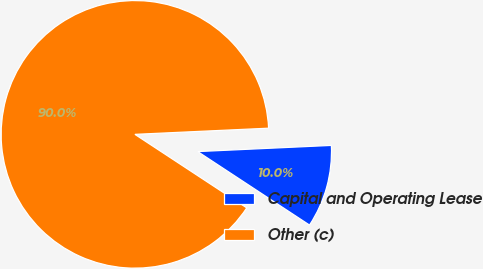<chart> <loc_0><loc_0><loc_500><loc_500><pie_chart><fcel>Capital and Operating Lease<fcel>Other (c)<nl><fcel>9.99%<fcel>90.01%<nl></chart> 